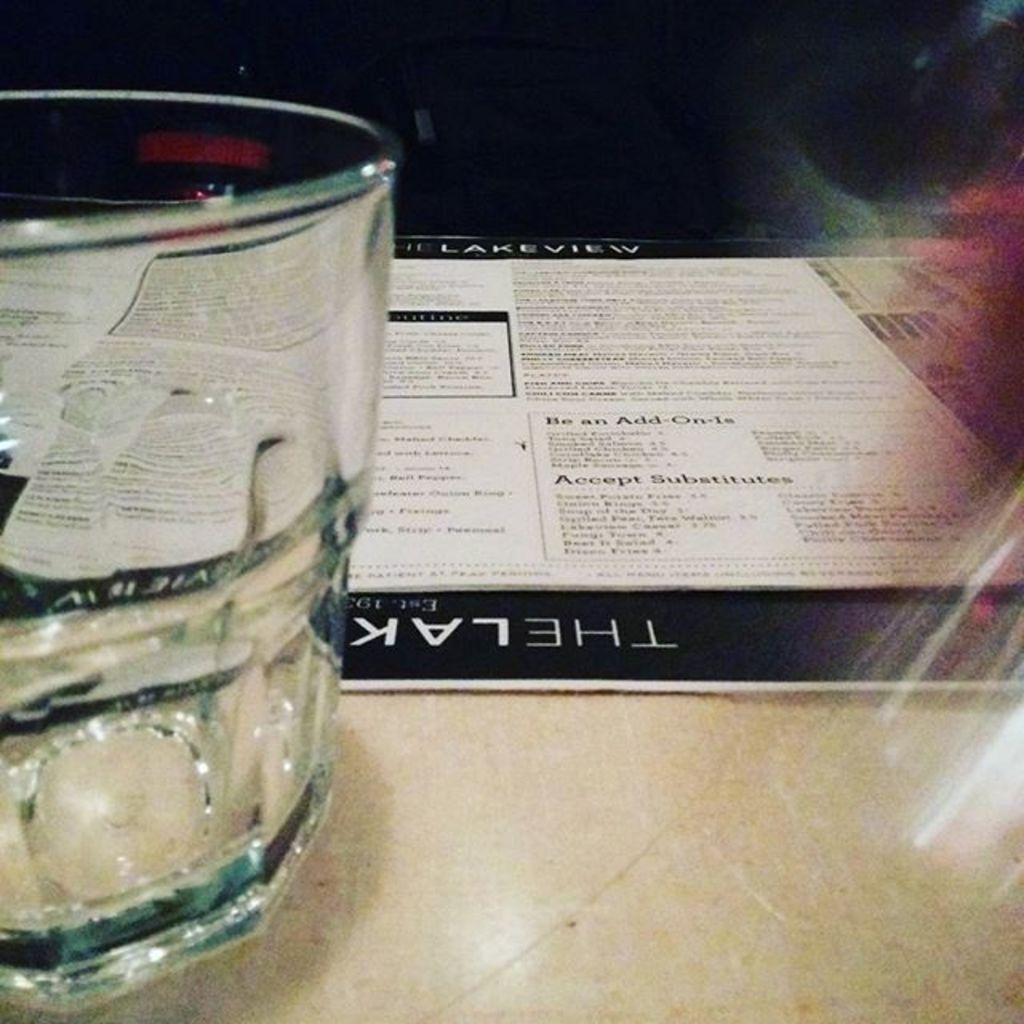<image>
Summarize the visual content of the image. A menu on the table tells us that we should Accept Substitutes. 